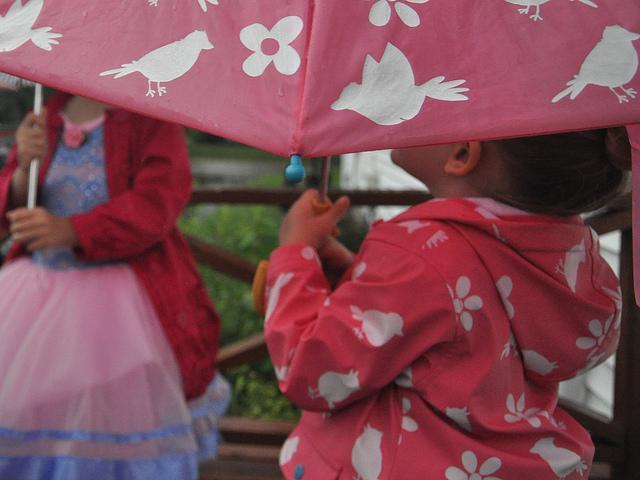How many children are in the picture?
Give a very brief answer. 2. How many people are there?
Give a very brief answer. 2. How many umbrellas are in the photo?
Give a very brief answer. 1. How many black cars are there?
Give a very brief answer. 0. 